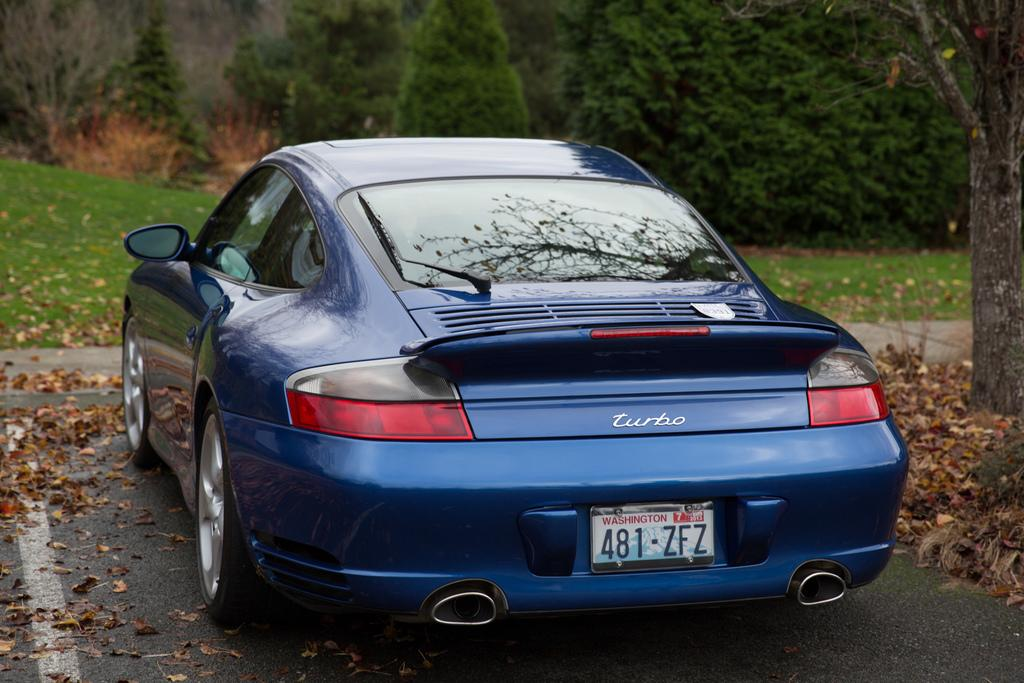<image>
Provide a brief description of the given image. A blue Porsche Turbo with a Washington tag that reads 481 ZFZ 